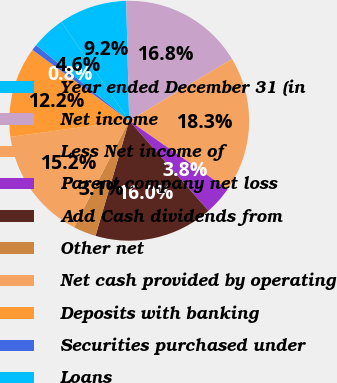Convert chart to OTSL. <chart><loc_0><loc_0><loc_500><loc_500><pie_chart><fcel>Year ended December 31 (in<fcel>Net income<fcel>Less Net income of<fcel>Parent company net loss<fcel>Add Cash dividends from<fcel>Other net<fcel>Net cash provided by operating<fcel>Deposits with banking<fcel>Securities purchased under<fcel>Loans<nl><fcel>9.16%<fcel>16.78%<fcel>18.3%<fcel>3.83%<fcel>16.02%<fcel>3.07%<fcel>15.25%<fcel>12.21%<fcel>0.79%<fcel>4.59%<nl></chart> 